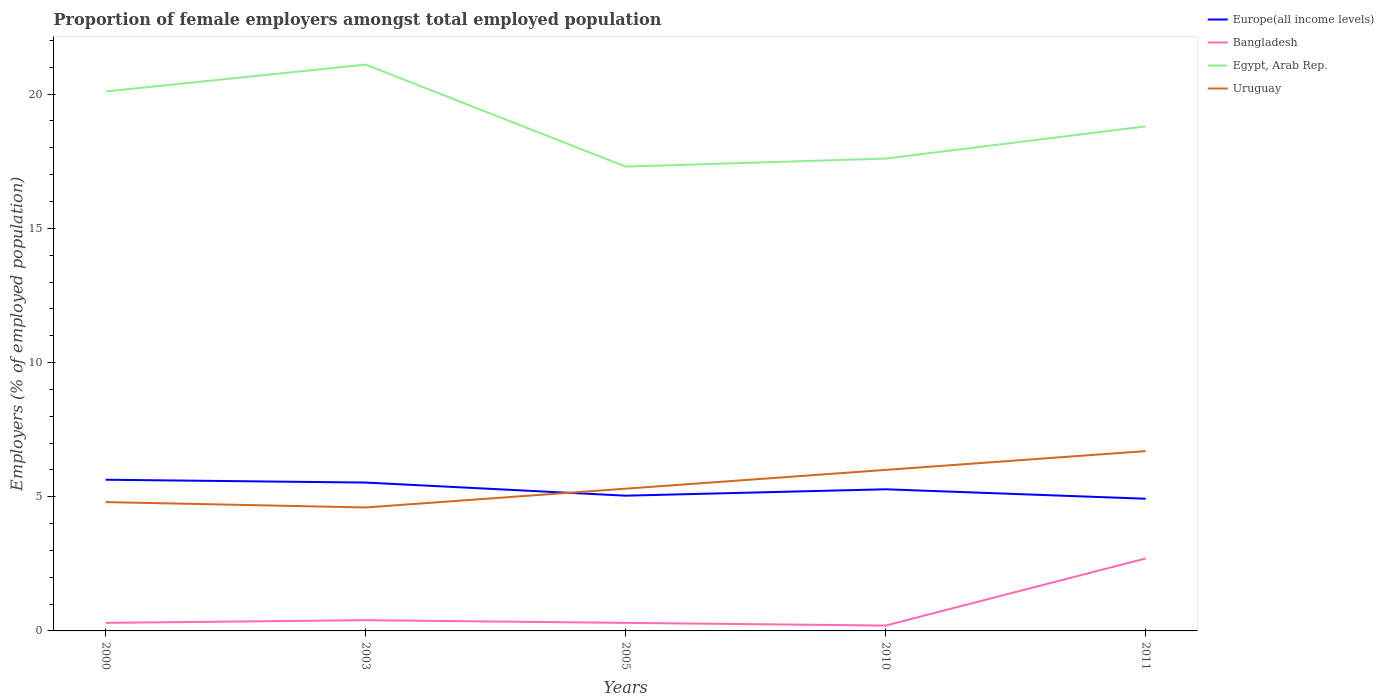How many different coloured lines are there?
Keep it short and to the point. 4. Does the line corresponding to Bangladesh intersect with the line corresponding to Europe(all income levels)?
Offer a terse response. No. Across all years, what is the maximum proportion of female employers in Bangladesh?
Your answer should be very brief. 0.2. What is the total proportion of female employers in Europe(all income levels) in the graph?
Your response must be concise. 0.71. What is the difference between the highest and the second highest proportion of female employers in Egypt, Arab Rep.?
Keep it short and to the point. 3.8. What is the difference between the highest and the lowest proportion of female employers in Uruguay?
Your response must be concise. 2. How many years are there in the graph?
Provide a short and direct response. 5. Are the values on the major ticks of Y-axis written in scientific E-notation?
Give a very brief answer. No. Where does the legend appear in the graph?
Your answer should be compact. Top right. What is the title of the graph?
Your answer should be very brief. Proportion of female employers amongst total employed population. Does "Malaysia" appear as one of the legend labels in the graph?
Provide a short and direct response. No. What is the label or title of the Y-axis?
Provide a short and direct response. Employers (% of employed population). What is the Employers (% of employed population) in Europe(all income levels) in 2000?
Make the answer very short. 5.63. What is the Employers (% of employed population) in Bangladesh in 2000?
Ensure brevity in your answer.  0.3. What is the Employers (% of employed population) of Egypt, Arab Rep. in 2000?
Keep it short and to the point. 20.1. What is the Employers (% of employed population) in Uruguay in 2000?
Keep it short and to the point. 4.8. What is the Employers (% of employed population) of Europe(all income levels) in 2003?
Your answer should be compact. 5.53. What is the Employers (% of employed population) of Bangladesh in 2003?
Your answer should be compact. 0.4. What is the Employers (% of employed population) in Egypt, Arab Rep. in 2003?
Your answer should be very brief. 21.1. What is the Employers (% of employed population) in Uruguay in 2003?
Your answer should be compact. 4.6. What is the Employers (% of employed population) in Europe(all income levels) in 2005?
Provide a short and direct response. 5.04. What is the Employers (% of employed population) in Bangladesh in 2005?
Your response must be concise. 0.3. What is the Employers (% of employed population) in Egypt, Arab Rep. in 2005?
Offer a terse response. 17.3. What is the Employers (% of employed population) in Uruguay in 2005?
Your response must be concise. 5.3. What is the Employers (% of employed population) of Europe(all income levels) in 2010?
Give a very brief answer. 5.28. What is the Employers (% of employed population) in Bangladesh in 2010?
Keep it short and to the point. 0.2. What is the Employers (% of employed population) in Egypt, Arab Rep. in 2010?
Your response must be concise. 17.6. What is the Employers (% of employed population) in Europe(all income levels) in 2011?
Provide a short and direct response. 4.93. What is the Employers (% of employed population) in Bangladesh in 2011?
Offer a very short reply. 2.7. What is the Employers (% of employed population) of Egypt, Arab Rep. in 2011?
Provide a short and direct response. 18.8. What is the Employers (% of employed population) of Uruguay in 2011?
Provide a succinct answer. 6.7. Across all years, what is the maximum Employers (% of employed population) in Europe(all income levels)?
Your response must be concise. 5.63. Across all years, what is the maximum Employers (% of employed population) of Bangladesh?
Your response must be concise. 2.7. Across all years, what is the maximum Employers (% of employed population) in Egypt, Arab Rep.?
Provide a succinct answer. 21.1. Across all years, what is the maximum Employers (% of employed population) in Uruguay?
Ensure brevity in your answer.  6.7. Across all years, what is the minimum Employers (% of employed population) of Europe(all income levels)?
Your response must be concise. 4.93. Across all years, what is the minimum Employers (% of employed population) of Bangladesh?
Your response must be concise. 0.2. Across all years, what is the minimum Employers (% of employed population) in Egypt, Arab Rep.?
Provide a short and direct response. 17.3. Across all years, what is the minimum Employers (% of employed population) of Uruguay?
Make the answer very short. 4.6. What is the total Employers (% of employed population) in Europe(all income levels) in the graph?
Ensure brevity in your answer.  26.4. What is the total Employers (% of employed population) in Bangladesh in the graph?
Provide a short and direct response. 3.9. What is the total Employers (% of employed population) of Egypt, Arab Rep. in the graph?
Make the answer very short. 94.9. What is the total Employers (% of employed population) in Uruguay in the graph?
Ensure brevity in your answer.  27.4. What is the difference between the Employers (% of employed population) of Europe(all income levels) in 2000 and that in 2003?
Your answer should be compact. 0.11. What is the difference between the Employers (% of employed population) of Uruguay in 2000 and that in 2003?
Give a very brief answer. 0.2. What is the difference between the Employers (% of employed population) of Europe(all income levels) in 2000 and that in 2005?
Keep it short and to the point. 0.59. What is the difference between the Employers (% of employed population) of Uruguay in 2000 and that in 2005?
Make the answer very short. -0.5. What is the difference between the Employers (% of employed population) in Europe(all income levels) in 2000 and that in 2010?
Make the answer very short. 0.36. What is the difference between the Employers (% of employed population) in Europe(all income levels) in 2000 and that in 2011?
Ensure brevity in your answer.  0.71. What is the difference between the Employers (% of employed population) in Bangladesh in 2000 and that in 2011?
Provide a succinct answer. -2.4. What is the difference between the Employers (% of employed population) in Egypt, Arab Rep. in 2000 and that in 2011?
Offer a very short reply. 1.3. What is the difference between the Employers (% of employed population) of Europe(all income levels) in 2003 and that in 2005?
Offer a very short reply. 0.49. What is the difference between the Employers (% of employed population) of Egypt, Arab Rep. in 2003 and that in 2005?
Provide a short and direct response. 3.8. What is the difference between the Employers (% of employed population) in Europe(all income levels) in 2003 and that in 2010?
Provide a short and direct response. 0.25. What is the difference between the Employers (% of employed population) of Bangladesh in 2003 and that in 2010?
Your response must be concise. 0.2. What is the difference between the Employers (% of employed population) in Egypt, Arab Rep. in 2003 and that in 2010?
Provide a succinct answer. 3.5. What is the difference between the Employers (% of employed population) in Uruguay in 2003 and that in 2010?
Keep it short and to the point. -1.4. What is the difference between the Employers (% of employed population) in Europe(all income levels) in 2003 and that in 2011?
Provide a succinct answer. 0.6. What is the difference between the Employers (% of employed population) in Egypt, Arab Rep. in 2003 and that in 2011?
Your answer should be very brief. 2.3. What is the difference between the Employers (% of employed population) in Uruguay in 2003 and that in 2011?
Provide a succinct answer. -2.1. What is the difference between the Employers (% of employed population) of Europe(all income levels) in 2005 and that in 2010?
Offer a terse response. -0.24. What is the difference between the Employers (% of employed population) of Europe(all income levels) in 2005 and that in 2011?
Your answer should be compact. 0.11. What is the difference between the Employers (% of employed population) of Bangladesh in 2005 and that in 2011?
Offer a terse response. -2.4. What is the difference between the Employers (% of employed population) of Europe(all income levels) in 2010 and that in 2011?
Your response must be concise. 0.35. What is the difference between the Employers (% of employed population) in Egypt, Arab Rep. in 2010 and that in 2011?
Provide a succinct answer. -1.2. What is the difference between the Employers (% of employed population) of Uruguay in 2010 and that in 2011?
Give a very brief answer. -0.7. What is the difference between the Employers (% of employed population) in Europe(all income levels) in 2000 and the Employers (% of employed population) in Bangladesh in 2003?
Provide a succinct answer. 5.23. What is the difference between the Employers (% of employed population) in Europe(all income levels) in 2000 and the Employers (% of employed population) in Egypt, Arab Rep. in 2003?
Your answer should be compact. -15.47. What is the difference between the Employers (% of employed population) of Europe(all income levels) in 2000 and the Employers (% of employed population) of Uruguay in 2003?
Your answer should be compact. 1.03. What is the difference between the Employers (% of employed population) of Bangladesh in 2000 and the Employers (% of employed population) of Egypt, Arab Rep. in 2003?
Provide a succinct answer. -20.8. What is the difference between the Employers (% of employed population) in Europe(all income levels) in 2000 and the Employers (% of employed population) in Bangladesh in 2005?
Provide a succinct answer. 5.33. What is the difference between the Employers (% of employed population) in Europe(all income levels) in 2000 and the Employers (% of employed population) in Egypt, Arab Rep. in 2005?
Your answer should be very brief. -11.67. What is the difference between the Employers (% of employed population) of Europe(all income levels) in 2000 and the Employers (% of employed population) of Uruguay in 2005?
Your answer should be very brief. 0.33. What is the difference between the Employers (% of employed population) in Bangladesh in 2000 and the Employers (% of employed population) in Egypt, Arab Rep. in 2005?
Your answer should be compact. -17. What is the difference between the Employers (% of employed population) in Europe(all income levels) in 2000 and the Employers (% of employed population) in Bangladesh in 2010?
Provide a short and direct response. 5.43. What is the difference between the Employers (% of employed population) in Europe(all income levels) in 2000 and the Employers (% of employed population) in Egypt, Arab Rep. in 2010?
Offer a terse response. -11.97. What is the difference between the Employers (% of employed population) in Europe(all income levels) in 2000 and the Employers (% of employed population) in Uruguay in 2010?
Your response must be concise. -0.37. What is the difference between the Employers (% of employed population) in Bangladesh in 2000 and the Employers (% of employed population) in Egypt, Arab Rep. in 2010?
Your response must be concise. -17.3. What is the difference between the Employers (% of employed population) of Bangladesh in 2000 and the Employers (% of employed population) of Uruguay in 2010?
Offer a terse response. -5.7. What is the difference between the Employers (% of employed population) in Europe(all income levels) in 2000 and the Employers (% of employed population) in Bangladesh in 2011?
Provide a short and direct response. 2.93. What is the difference between the Employers (% of employed population) in Europe(all income levels) in 2000 and the Employers (% of employed population) in Egypt, Arab Rep. in 2011?
Ensure brevity in your answer.  -13.17. What is the difference between the Employers (% of employed population) of Europe(all income levels) in 2000 and the Employers (% of employed population) of Uruguay in 2011?
Provide a short and direct response. -1.07. What is the difference between the Employers (% of employed population) in Bangladesh in 2000 and the Employers (% of employed population) in Egypt, Arab Rep. in 2011?
Your answer should be very brief. -18.5. What is the difference between the Employers (% of employed population) of Egypt, Arab Rep. in 2000 and the Employers (% of employed population) of Uruguay in 2011?
Offer a very short reply. 13.4. What is the difference between the Employers (% of employed population) in Europe(all income levels) in 2003 and the Employers (% of employed population) in Bangladesh in 2005?
Keep it short and to the point. 5.23. What is the difference between the Employers (% of employed population) in Europe(all income levels) in 2003 and the Employers (% of employed population) in Egypt, Arab Rep. in 2005?
Ensure brevity in your answer.  -11.77. What is the difference between the Employers (% of employed population) in Europe(all income levels) in 2003 and the Employers (% of employed population) in Uruguay in 2005?
Provide a short and direct response. 0.23. What is the difference between the Employers (% of employed population) in Bangladesh in 2003 and the Employers (% of employed population) in Egypt, Arab Rep. in 2005?
Your answer should be compact. -16.9. What is the difference between the Employers (% of employed population) of Egypt, Arab Rep. in 2003 and the Employers (% of employed population) of Uruguay in 2005?
Offer a terse response. 15.8. What is the difference between the Employers (% of employed population) of Europe(all income levels) in 2003 and the Employers (% of employed population) of Bangladesh in 2010?
Give a very brief answer. 5.33. What is the difference between the Employers (% of employed population) of Europe(all income levels) in 2003 and the Employers (% of employed population) of Egypt, Arab Rep. in 2010?
Provide a succinct answer. -12.07. What is the difference between the Employers (% of employed population) in Europe(all income levels) in 2003 and the Employers (% of employed population) in Uruguay in 2010?
Offer a terse response. -0.47. What is the difference between the Employers (% of employed population) in Bangladesh in 2003 and the Employers (% of employed population) in Egypt, Arab Rep. in 2010?
Ensure brevity in your answer.  -17.2. What is the difference between the Employers (% of employed population) of Europe(all income levels) in 2003 and the Employers (% of employed population) of Bangladesh in 2011?
Keep it short and to the point. 2.83. What is the difference between the Employers (% of employed population) in Europe(all income levels) in 2003 and the Employers (% of employed population) in Egypt, Arab Rep. in 2011?
Ensure brevity in your answer.  -13.27. What is the difference between the Employers (% of employed population) of Europe(all income levels) in 2003 and the Employers (% of employed population) of Uruguay in 2011?
Your answer should be compact. -1.17. What is the difference between the Employers (% of employed population) of Bangladesh in 2003 and the Employers (% of employed population) of Egypt, Arab Rep. in 2011?
Keep it short and to the point. -18.4. What is the difference between the Employers (% of employed population) in Bangladesh in 2003 and the Employers (% of employed population) in Uruguay in 2011?
Your answer should be compact. -6.3. What is the difference between the Employers (% of employed population) in Egypt, Arab Rep. in 2003 and the Employers (% of employed population) in Uruguay in 2011?
Your answer should be compact. 14.4. What is the difference between the Employers (% of employed population) of Europe(all income levels) in 2005 and the Employers (% of employed population) of Bangladesh in 2010?
Offer a terse response. 4.84. What is the difference between the Employers (% of employed population) of Europe(all income levels) in 2005 and the Employers (% of employed population) of Egypt, Arab Rep. in 2010?
Ensure brevity in your answer.  -12.56. What is the difference between the Employers (% of employed population) in Europe(all income levels) in 2005 and the Employers (% of employed population) in Uruguay in 2010?
Your answer should be compact. -0.96. What is the difference between the Employers (% of employed population) of Bangladesh in 2005 and the Employers (% of employed population) of Egypt, Arab Rep. in 2010?
Give a very brief answer. -17.3. What is the difference between the Employers (% of employed population) in Europe(all income levels) in 2005 and the Employers (% of employed population) in Bangladesh in 2011?
Make the answer very short. 2.34. What is the difference between the Employers (% of employed population) of Europe(all income levels) in 2005 and the Employers (% of employed population) of Egypt, Arab Rep. in 2011?
Provide a succinct answer. -13.76. What is the difference between the Employers (% of employed population) in Europe(all income levels) in 2005 and the Employers (% of employed population) in Uruguay in 2011?
Give a very brief answer. -1.66. What is the difference between the Employers (% of employed population) in Bangladesh in 2005 and the Employers (% of employed population) in Egypt, Arab Rep. in 2011?
Make the answer very short. -18.5. What is the difference between the Employers (% of employed population) of Europe(all income levels) in 2010 and the Employers (% of employed population) of Bangladesh in 2011?
Make the answer very short. 2.58. What is the difference between the Employers (% of employed population) of Europe(all income levels) in 2010 and the Employers (% of employed population) of Egypt, Arab Rep. in 2011?
Your answer should be very brief. -13.52. What is the difference between the Employers (% of employed population) of Europe(all income levels) in 2010 and the Employers (% of employed population) of Uruguay in 2011?
Provide a short and direct response. -1.42. What is the difference between the Employers (% of employed population) in Bangladesh in 2010 and the Employers (% of employed population) in Egypt, Arab Rep. in 2011?
Ensure brevity in your answer.  -18.6. What is the difference between the Employers (% of employed population) of Bangladesh in 2010 and the Employers (% of employed population) of Uruguay in 2011?
Make the answer very short. -6.5. What is the average Employers (% of employed population) of Europe(all income levels) per year?
Keep it short and to the point. 5.28. What is the average Employers (% of employed population) in Bangladesh per year?
Keep it short and to the point. 0.78. What is the average Employers (% of employed population) in Egypt, Arab Rep. per year?
Offer a terse response. 18.98. What is the average Employers (% of employed population) of Uruguay per year?
Ensure brevity in your answer.  5.48. In the year 2000, what is the difference between the Employers (% of employed population) in Europe(all income levels) and Employers (% of employed population) in Bangladesh?
Your response must be concise. 5.33. In the year 2000, what is the difference between the Employers (% of employed population) in Europe(all income levels) and Employers (% of employed population) in Egypt, Arab Rep.?
Your answer should be very brief. -14.47. In the year 2000, what is the difference between the Employers (% of employed population) of Europe(all income levels) and Employers (% of employed population) of Uruguay?
Make the answer very short. 0.83. In the year 2000, what is the difference between the Employers (% of employed population) in Bangladesh and Employers (% of employed population) in Egypt, Arab Rep.?
Make the answer very short. -19.8. In the year 2003, what is the difference between the Employers (% of employed population) in Europe(all income levels) and Employers (% of employed population) in Bangladesh?
Offer a very short reply. 5.13. In the year 2003, what is the difference between the Employers (% of employed population) in Europe(all income levels) and Employers (% of employed population) in Egypt, Arab Rep.?
Make the answer very short. -15.57. In the year 2003, what is the difference between the Employers (% of employed population) in Europe(all income levels) and Employers (% of employed population) in Uruguay?
Ensure brevity in your answer.  0.93. In the year 2003, what is the difference between the Employers (% of employed population) in Bangladesh and Employers (% of employed population) in Egypt, Arab Rep.?
Keep it short and to the point. -20.7. In the year 2005, what is the difference between the Employers (% of employed population) of Europe(all income levels) and Employers (% of employed population) of Bangladesh?
Provide a short and direct response. 4.74. In the year 2005, what is the difference between the Employers (% of employed population) in Europe(all income levels) and Employers (% of employed population) in Egypt, Arab Rep.?
Give a very brief answer. -12.26. In the year 2005, what is the difference between the Employers (% of employed population) in Europe(all income levels) and Employers (% of employed population) in Uruguay?
Your answer should be compact. -0.26. In the year 2005, what is the difference between the Employers (% of employed population) of Bangladesh and Employers (% of employed population) of Uruguay?
Offer a terse response. -5. In the year 2010, what is the difference between the Employers (% of employed population) in Europe(all income levels) and Employers (% of employed population) in Bangladesh?
Make the answer very short. 5.08. In the year 2010, what is the difference between the Employers (% of employed population) of Europe(all income levels) and Employers (% of employed population) of Egypt, Arab Rep.?
Provide a short and direct response. -12.32. In the year 2010, what is the difference between the Employers (% of employed population) of Europe(all income levels) and Employers (% of employed population) of Uruguay?
Make the answer very short. -0.72. In the year 2010, what is the difference between the Employers (% of employed population) in Bangladesh and Employers (% of employed population) in Egypt, Arab Rep.?
Your answer should be very brief. -17.4. In the year 2010, what is the difference between the Employers (% of employed population) in Egypt, Arab Rep. and Employers (% of employed population) in Uruguay?
Make the answer very short. 11.6. In the year 2011, what is the difference between the Employers (% of employed population) in Europe(all income levels) and Employers (% of employed population) in Bangladesh?
Keep it short and to the point. 2.23. In the year 2011, what is the difference between the Employers (% of employed population) of Europe(all income levels) and Employers (% of employed population) of Egypt, Arab Rep.?
Your answer should be very brief. -13.87. In the year 2011, what is the difference between the Employers (% of employed population) in Europe(all income levels) and Employers (% of employed population) in Uruguay?
Ensure brevity in your answer.  -1.77. In the year 2011, what is the difference between the Employers (% of employed population) in Bangladesh and Employers (% of employed population) in Egypt, Arab Rep.?
Provide a short and direct response. -16.1. In the year 2011, what is the difference between the Employers (% of employed population) of Bangladesh and Employers (% of employed population) of Uruguay?
Provide a short and direct response. -4. What is the ratio of the Employers (% of employed population) of Europe(all income levels) in 2000 to that in 2003?
Ensure brevity in your answer.  1.02. What is the ratio of the Employers (% of employed population) of Egypt, Arab Rep. in 2000 to that in 2003?
Your answer should be compact. 0.95. What is the ratio of the Employers (% of employed population) in Uruguay in 2000 to that in 2003?
Provide a succinct answer. 1.04. What is the ratio of the Employers (% of employed population) of Europe(all income levels) in 2000 to that in 2005?
Make the answer very short. 1.12. What is the ratio of the Employers (% of employed population) of Egypt, Arab Rep. in 2000 to that in 2005?
Offer a very short reply. 1.16. What is the ratio of the Employers (% of employed population) in Uruguay in 2000 to that in 2005?
Give a very brief answer. 0.91. What is the ratio of the Employers (% of employed population) of Europe(all income levels) in 2000 to that in 2010?
Your answer should be compact. 1.07. What is the ratio of the Employers (% of employed population) in Bangladesh in 2000 to that in 2010?
Your response must be concise. 1.5. What is the ratio of the Employers (% of employed population) of Egypt, Arab Rep. in 2000 to that in 2010?
Offer a very short reply. 1.14. What is the ratio of the Employers (% of employed population) in Europe(all income levels) in 2000 to that in 2011?
Make the answer very short. 1.14. What is the ratio of the Employers (% of employed population) of Bangladesh in 2000 to that in 2011?
Your answer should be very brief. 0.11. What is the ratio of the Employers (% of employed population) in Egypt, Arab Rep. in 2000 to that in 2011?
Provide a succinct answer. 1.07. What is the ratio of the Employers (% of employed population) in Uruguay in 2000 to that in 2011?
Make the answer very short. 0.72. What is the ratio of the Employers (% of employed population) of Europe(all income levels) in 2003 to that in 2005?
Your response must be concise. 1.1. What is the ratio of the Employers (% of employed population) of Bangladesh in 2003 to that in 2005?
Ensure brevity in your answer.  1.33. What is the ratio of the Employers (% of employed population) in Egypt, Arab Rep. in 2003 to that in 2005?
Your answer should be compact. 1.22. What is the ratio of the Employers (% of employed population) in Uruguay in 2003 to that in 2005?
Provide a short and direct response. 0.87. What is the ratio of the Employers (% of employed population) in Europe(all income levels) in 2003 to that in 2010?
Offer a very short reply. 1.05. What is the ratio of the Employers (% of employed population) in Bangladesh in 2003 to that in 2010?
Offer a terse response. 2. What is the ratio of the Employers (% of employed population) in Egypt, Arab Rep. in 2003 to that in 2010?
Make the answer very short. 1.2. What is the ratio of the Employers (% of employed population) in Uruguay in 2003 to that in 2010?
Your answer should be compact. 0.77. What is the ratio of the Employers (% of employed population) of Europe(all income levels) in 2003 to that in 2011?
Offer a terse response. 1.12. What is the ratio of the Employers (% of employed population) of Bangladesh in 2003 to that in 2011?
Your response must be concise. 0.15. What is the ratio of the Employers (% of employed population) of Egypt, Arab Rep. in 2003 to that in 2011?
Your answer should be compact. 1.12. What is the ratio of the Employers (% of employed population) in Uruguay in 2003 to that in 2011?
Keep it short and to the point. 0.69. What is the ratio of the Employers (% of employed population) of Europe(all income levels) in 2005 to that in 2010?
Keep it short and to the point. 0.95. What is the ratio of the Employers (% of employed population) of Uruguay in 2005 to that in 2010?
Ensure brevity in your answer.  0.88. What is the ratio of the Employers (% of employed population) in Europe(all income levels) in 2005 to that in 2011?
Your response must be concise. 1.02. What is the ratio of the Employers (% of employed population) of Egypt, Arab Rep. in 2005 to that in 2011?
Offer a very short reply. 0.92. What is the ratio of the Employers (% of employed population) of Uruguay in 2005 to that in 2011?
Provide a short and direct response. 0.79. What is the ratio of the Employers (% of employed population) of Europe(all income levels) in 2010 to that in 2011?
Provide a succinct answer. 1.07. What is the ratio of the Employers (% of employed population) of Bangladesh in 2010 to that in 2011?
Give a very brief answer. 0.07. What is the ratio of the Employers (% of employed population) of Egypt, Arab Rep. in 2010 to that in 2011?
Your answer should be very brief. 0.94. What is the ratio of the Employers (% of employed population) in Uruguay in 2010 to that in 2011?
Ensure brevity in your answer.  0.9. What is the difference between the highest and the second highest Employers (% of employed population) in Europe(all income levels)?
Ensure brevity in your answer.  0.11. What is the difference between the highest and the second highest Employers (% of employed population) of Egypt, Arab Rep.?
Make the answer very short. 1. What is the difference between the highest and the second highest Employers (% of employed population) of Uruguay?
Your response must be concise. 0.7. What is the difference between the highest and the lowest Employers (% of employed population) of Europe(all income levels)?
Make the answer very short. 0.71. 